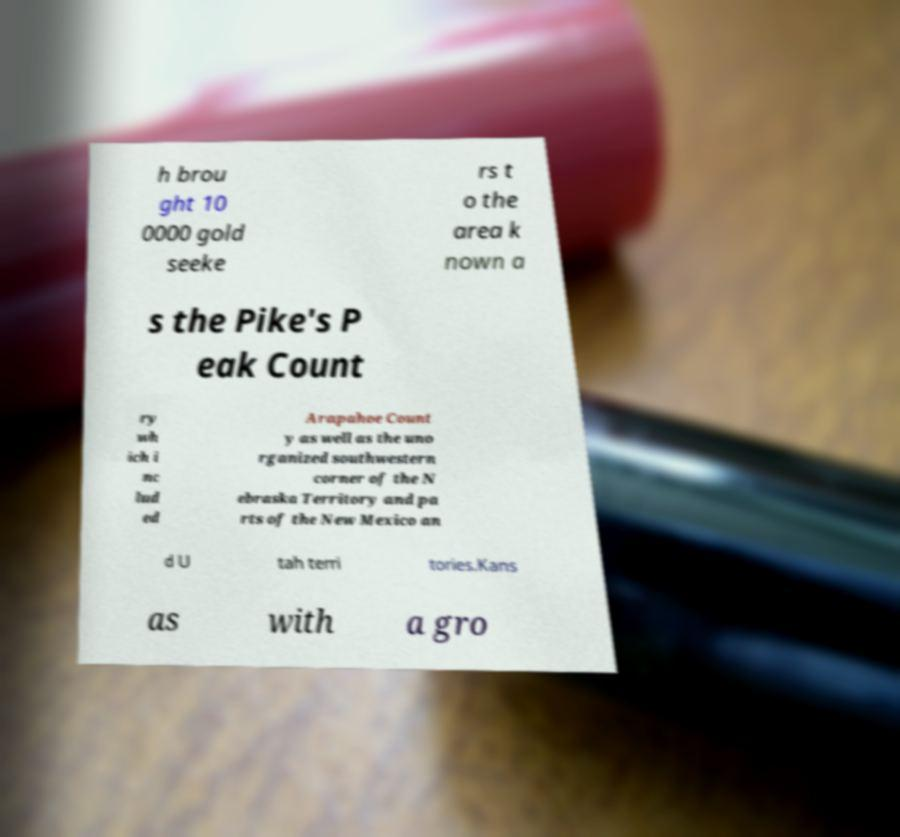Can you accurately transcribe the text from the provided image for me? h brou ght 10 0000 gold seeke rs t o the area k nown a s the Pike's P eak Count ry wh ich i nc lud ed Arapahoe Count y as well as the uno rganized southwestern corner of the N ebraska Territory and pa rts of the New Mexico an d U tah terri tories.Kans as with a gro 